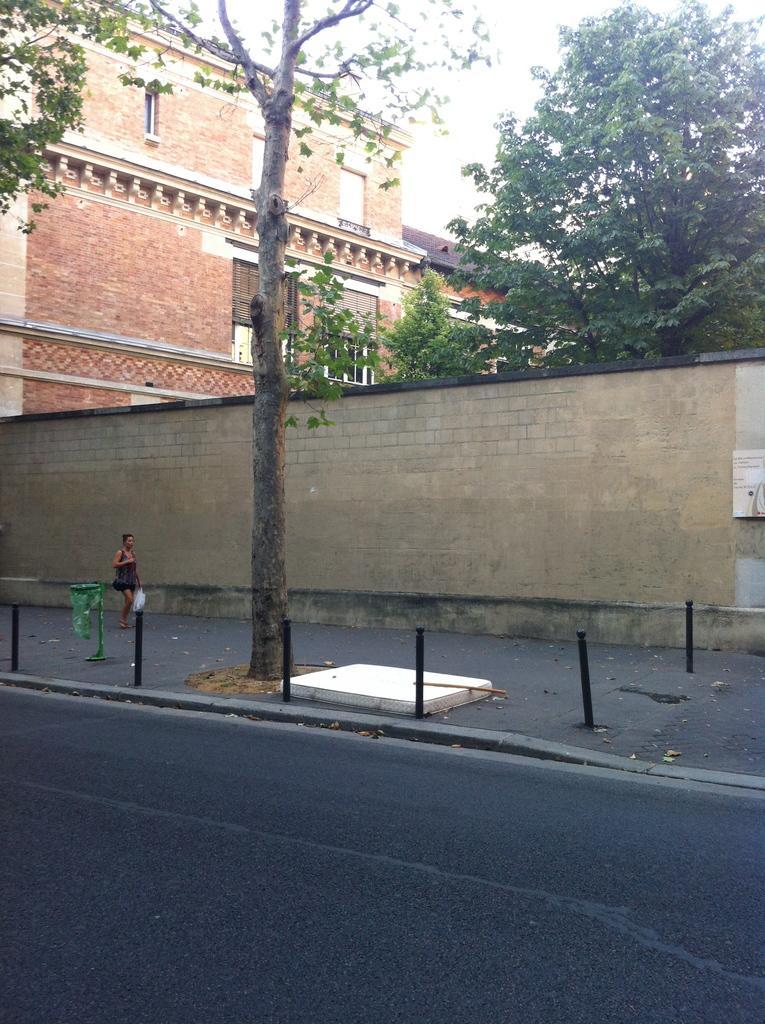How would you summarize this image in a sentence or two? In the foreground I can see a woman on the road, poles and a wall fence. In the background I can see buildings, trees and the sky. This image is taken during a day on the road. 